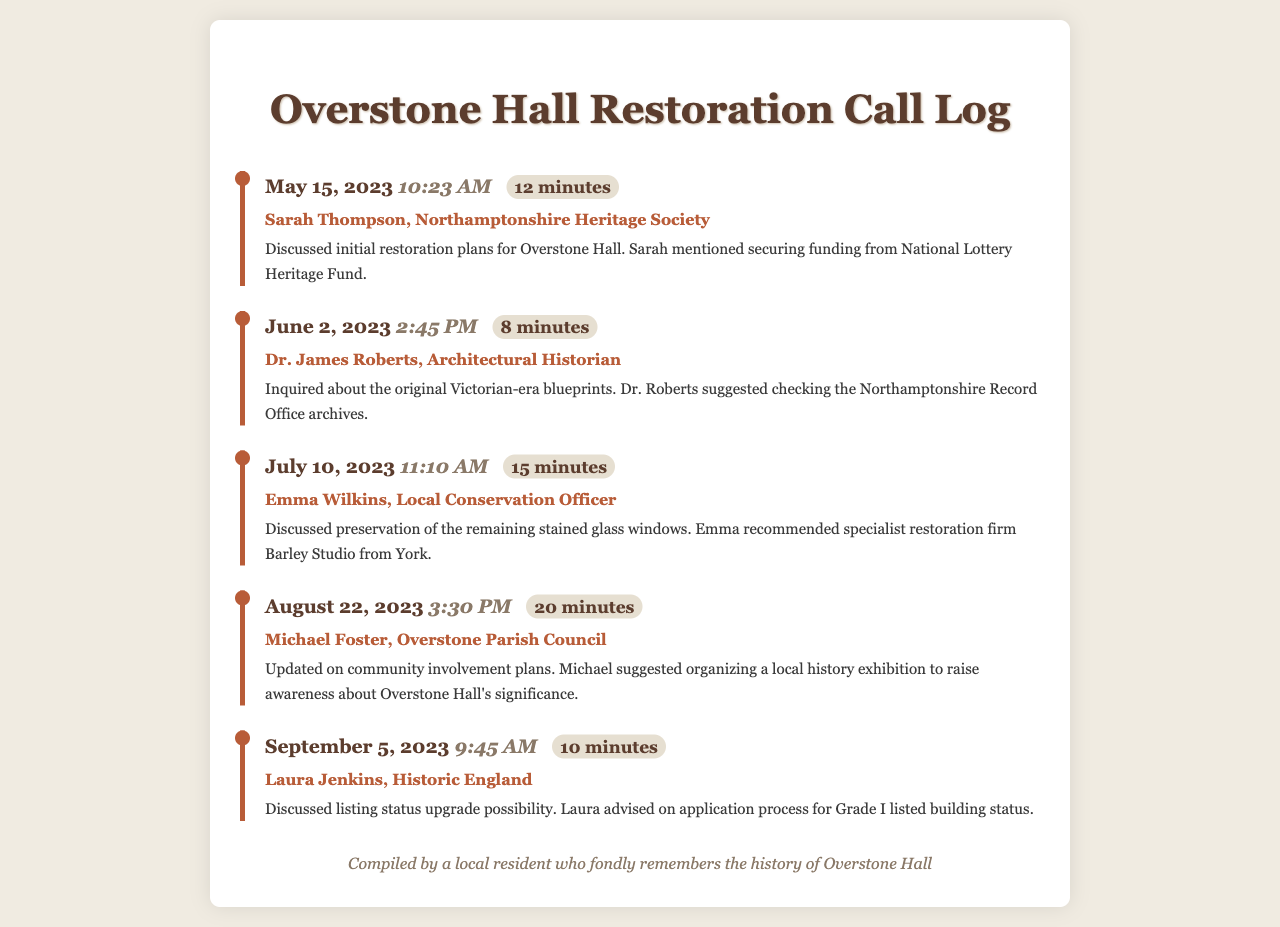What date was the call with Sarah Thompson? The call with Sarah Thompson occurred on May 15, 2023, as noted in the call log.
Answer: May 15, 2023 Who was consulted about the Victorian-era blueprints? Dr. James Roberts was the person who inquired about the original Victorian-era blueprints during the call.
Answer: Dr. James Roberts How long was the conversation with Emma Wilkins? The call with Emma Wilkins lasted for 15 minutes, as seen in the duration noted in the log.
Answer: 15 minutes What was discussed during the call with Michael Foster? The call with Michael Foster involved updating on community involvement plans relating to Overstone Hall.
Answer: Community involvement plans Which firm did Emma recommend for stained glass window restoration? Emma recommended Barley Studio from York for the restoration of stained glass windows in the call.
Answer: Barley Studio What is the purpose of the call with Laura Jenkins? The call with Laura Jenkins was focused on discussing the listing status upgrade possibility for Overstone Hall.
Answer: Listing status upgrade Who is involved in the restoration efforts of Overstone Hall? The individuals involved in the restoration efforts include Sarah Thompson, Dr. James Roberts, Emma Wilkins, Michael Foster, and Laura Jenkins.
Answer: Sarah Thompson, Dr. James Roberts, Emma Wilkins, Michael Foster, Laura Jenkins What heritage funding was mentioned in the first call? The National Lottery Heritage Fund was mentioned as the source of funding in the first call.
Answer: National Lottery Heritage Fund 